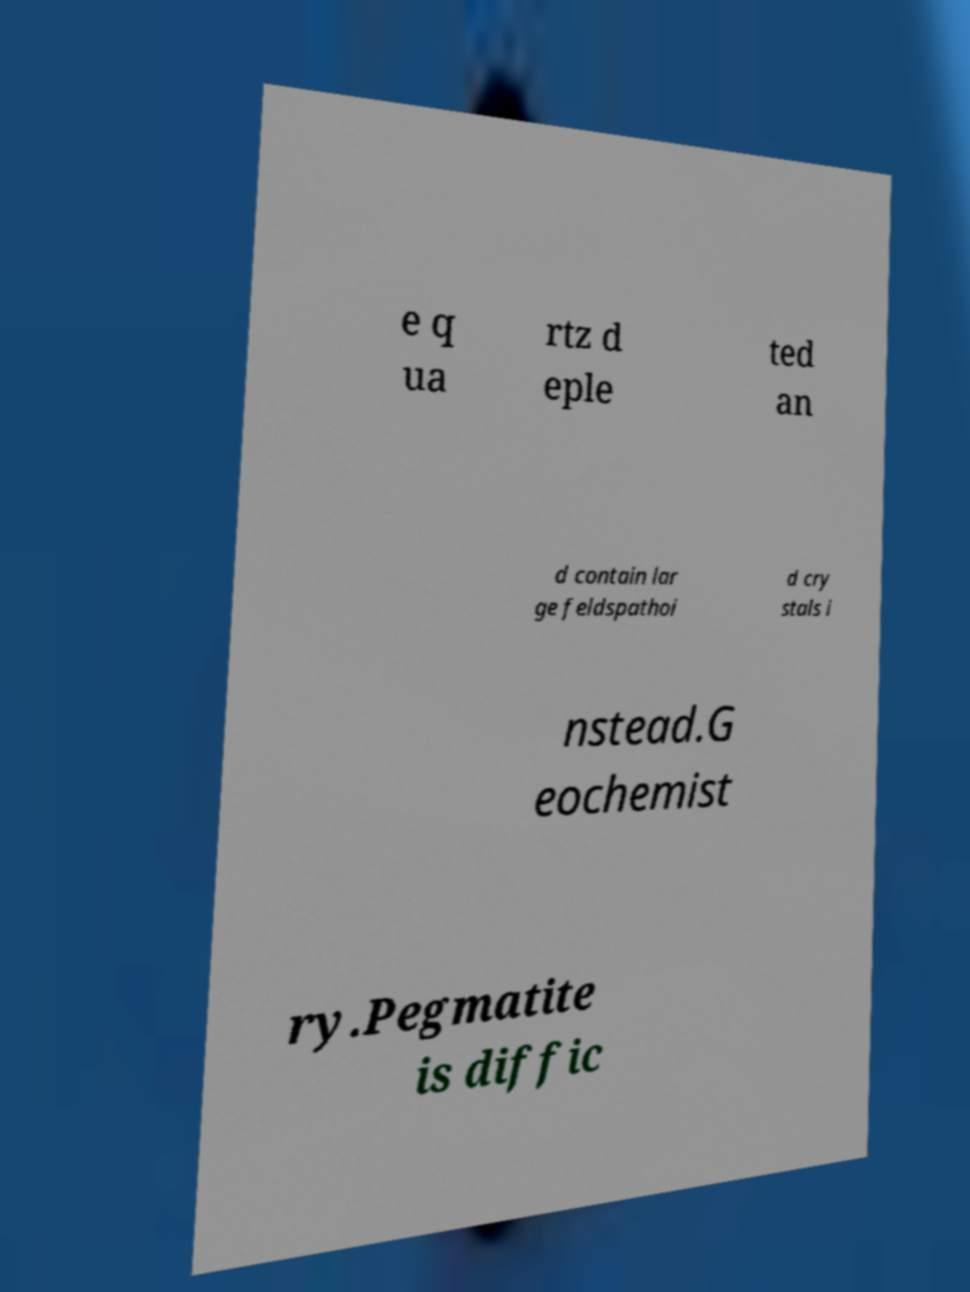Please read and relay the text visible in this image. What does it say? e q ua rtz d eple ted an d contain lar ge feldspathoi d cry stals i nstead.G eochemist ry.Pegmatite is diffic 